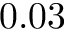Convert formula to latex. <formula><loc_0><loc_0><loc_500><loc_500>0 . 0 3</formula> 